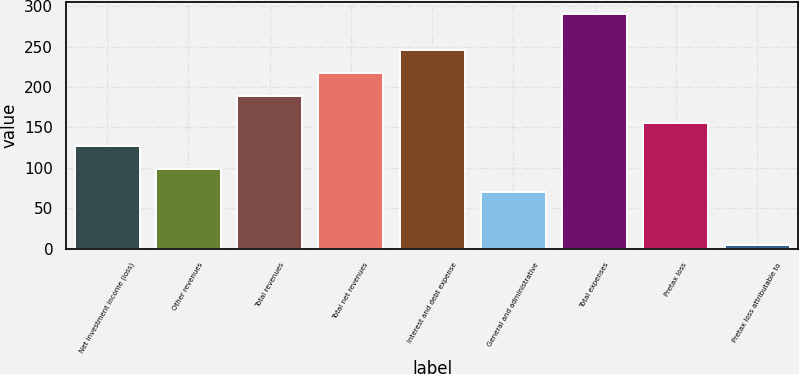Convert chart to OTSL. <chart><loc_0><loc_0><loc_500><loc_500><bar_chart><fcel>Net investment income (loss)<fcel>Other revenues<fcel>Total revenues<fcel>Total net revenues<fcel>Interest and debt expense<fcel>General and administrative<fcel>Total expenses<fcel>Pretax loss<fcel>Pretax loss attributable to<nl><fcel>127.4<fcel>98.7<fcel>189<fcel>217.7<fcel>246.4<fcel>70<fcel>291<fcel>156.1<fcel>4<nl></chart> 